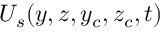Convert formula to latex. <formula><loc_0><loc_0><loc_500><loc_500>U _ { s } ( y , z , y _ { c } , z _ { c } , t )</formula> 